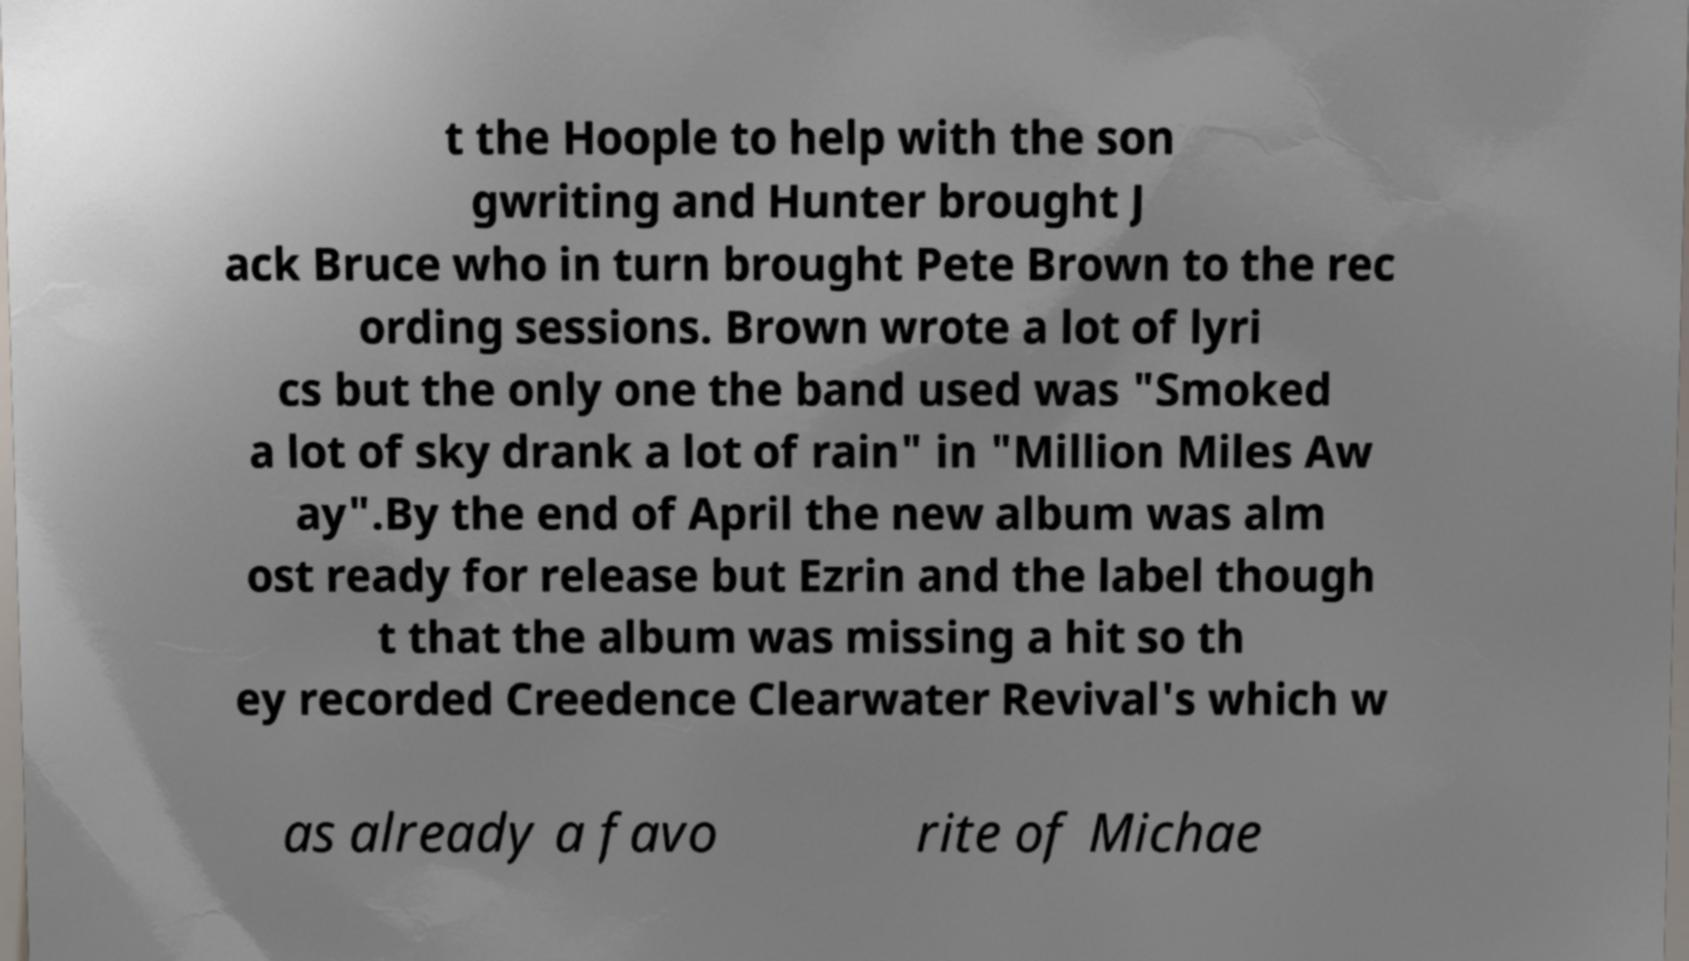Could you assist in decoding the text presented in this image and type it out clearly? t the Hoople to help with the son gwriting and Hunter brought J ack Bruce who in turn brought Pete Brown to the rec ording sessions. Brown wrote a lot of lyri cs but the only one the band used was "Smoked a lot of sky drank a lot of rain" in "Million Miles Aw ay".By the end of April the new album was alm ost ready for release but Ezrin and the label though t that the album was missing a hit so th ey recorded Creedence Clearwater Revival's which w as already a favo rite of Michae 